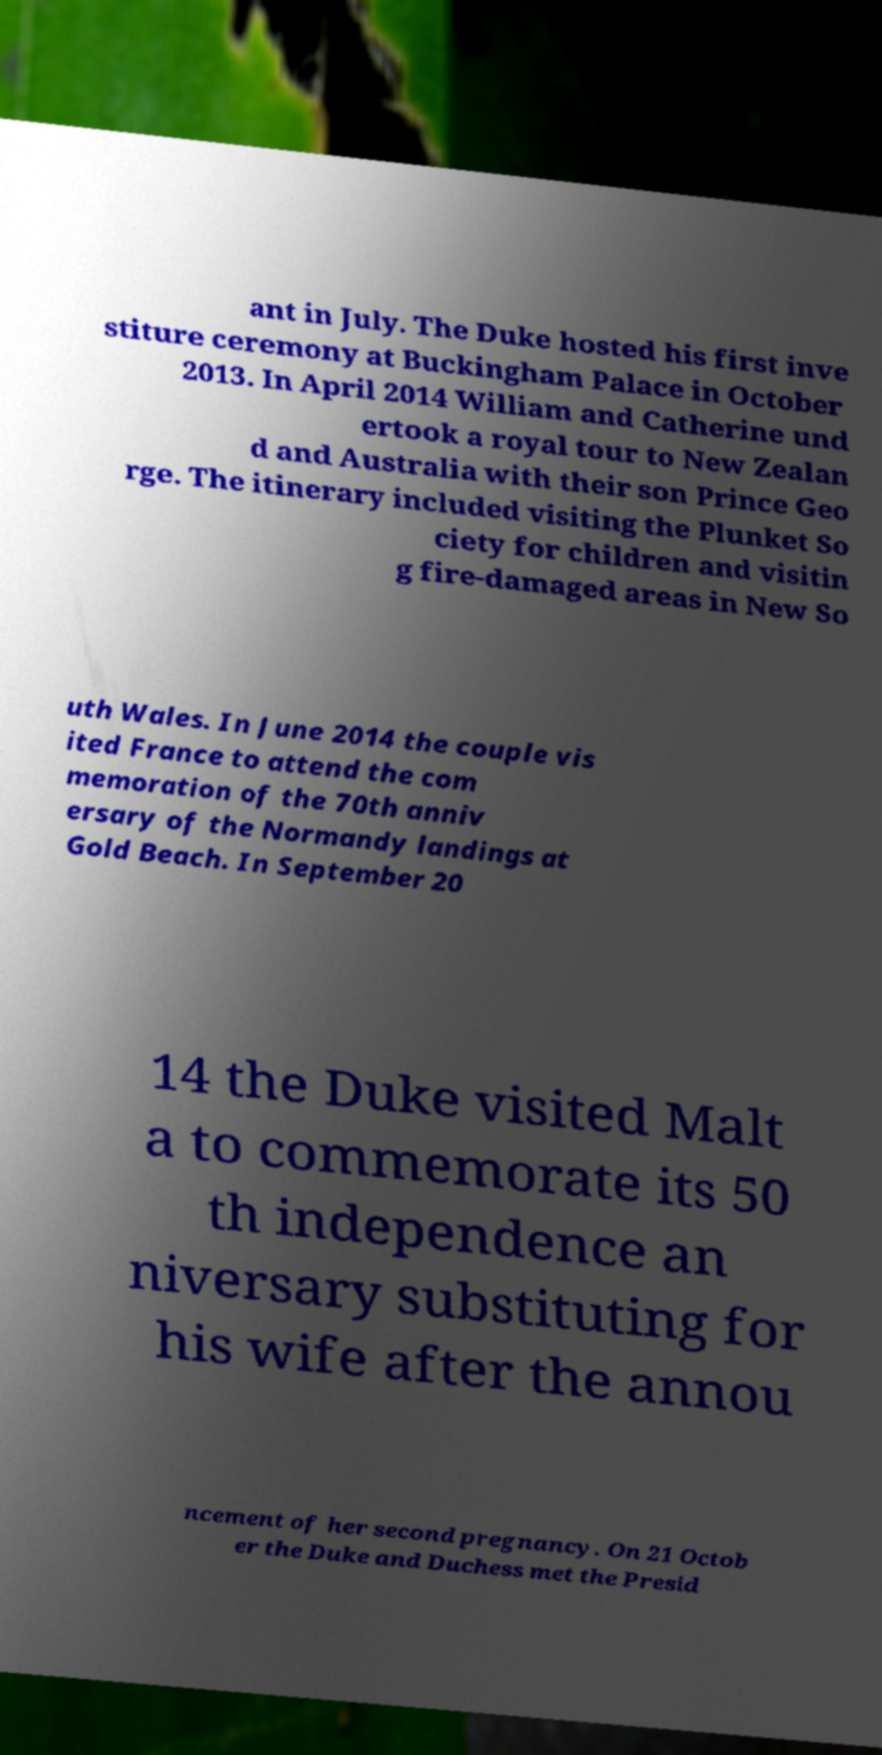Can you read and provide the text displayed in the image?This photo seems to have some interesting text. Can you extract and type it out for me? ant in July. The Duke hosted his first inve stiture ceremony at Buckingham Palace in October 2013. In April 2014 William and Catherine und ertook a royal tour to New Zealan d and Australia with their son Prince Geo rge. The itinerary included visiting the Plunket So ciety for children and visitin g fire-damaged areas in New So uth Wales. In June 2014 the couple vis ited France to attend the com memoration of the 70th anniv ersary of the Normandy landings at Gold Beach. In September 20 14 the Duke visited Malt a to commemorate its 50 th independence an niversary substituting for his wife after the annou ncement of her second pregnancy. On 21 Octob er the Duke and Duchess met the Presid 